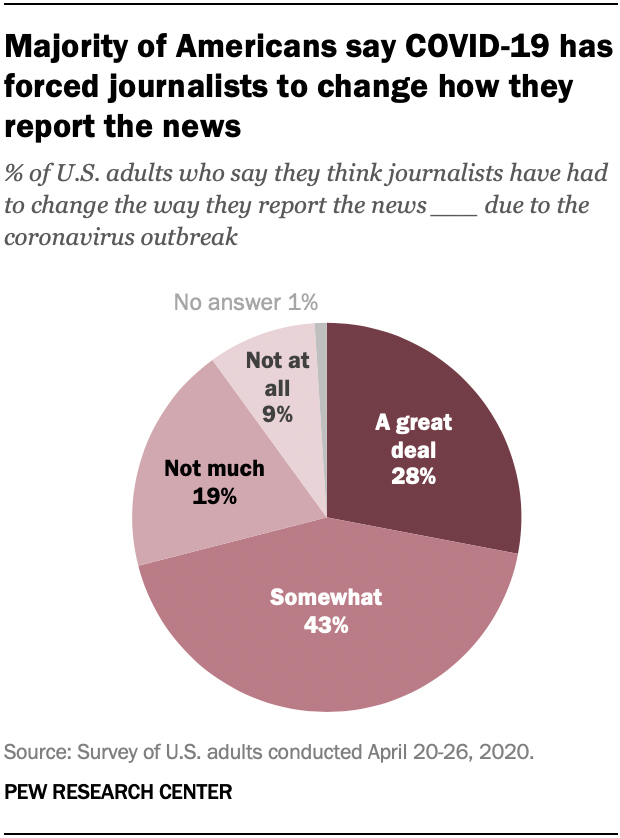Draw attention to some important aspects in this diagram. The largest value in the graph is 0.43. The value difference between 'A great deal' and 'Not much' is 0.09. 